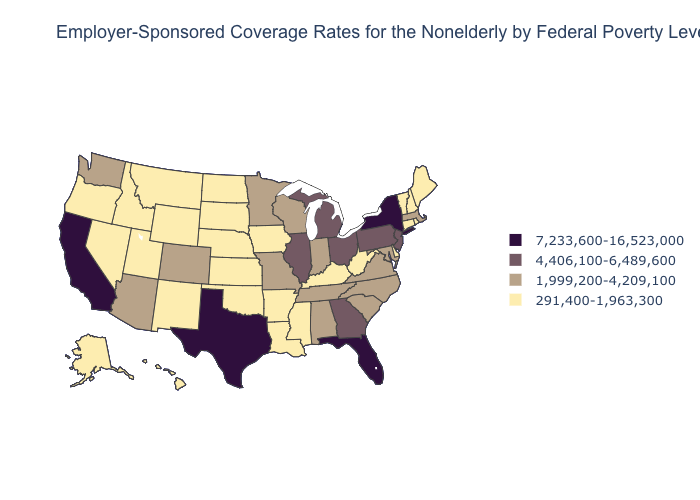Does Connecticut have the lowest value in the Northeast?
Short answer required. Yes. Name the states that have a value in the range 4,406,100-6,489,600?
Short answer required. Georgia, Illinois, Michigan, New Jersey, Ohio, Pennsylvania. Does Wyoming have the lowest value in the USA?
Quick response, please. Yes. What is the highest value in the West ?
Quick response, please. 7,233,600-16,523,000. Which states have the highest value in the USA?
Be succinct. California, Florida, New York, Texas. Among the states that border Colorado , which have the lowest value?
Be succinct. Kansas, Nebraska, New Mexico, Oklahoma, Utah, Wyoming. Does Alabama have a higher value than Pennsylvania?
Short answer required. No. Which states hav the highest value in the South?
Concise answer only. Florida, Texas. Which states hav the highest value in the MidWest?
Quick response, please. Illinois, Michigan, Ohio. Does Arkansas have the highest value in the South?
Quick response, please. No. Which states have the lowest value in the West?
Short answer required. Alaska, Hawaii, Idaho, Montana, Nevada, New Mexico, Oregon, Utah, Wyoming. What is the lowest value in states that border Kansas?
Concise answer only. 291,400-1,963,300. What is the value of Massachusetts?
Concise answer only. 1,999,200-4,209,100. Does Kentucky have the lowest value in the USA?
Write a very short answer. Yes. What is the lowest value in the USA?
Answer briefly. 291,400-1,963,300. 